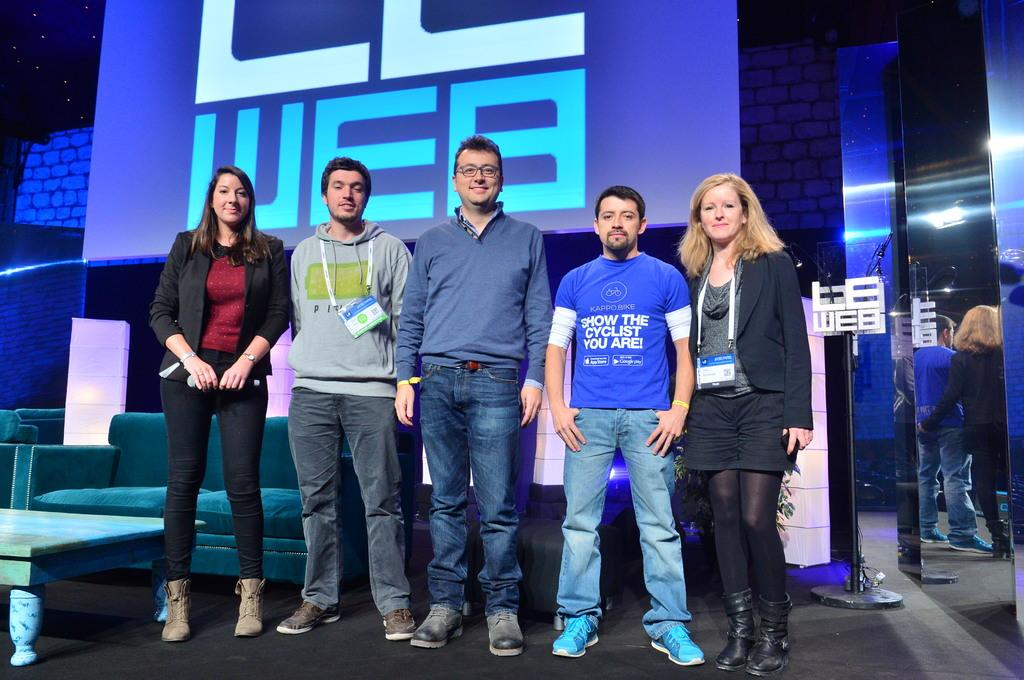What can be seen in the image in terms of living beings? There are people in the image. What type of furniture is present in the image? There is a sofa and a table in the image. What kind of object is visible on the wall or hanging from the ceiling? There is a screen in the image. How many eyes can be seen on the quince in the image? There is no quince present in the image, and therefore no eyes can be seen on it. What type of tool is being used by the people in the image? The provided facts do not mention any tools being used by the people in the image. 